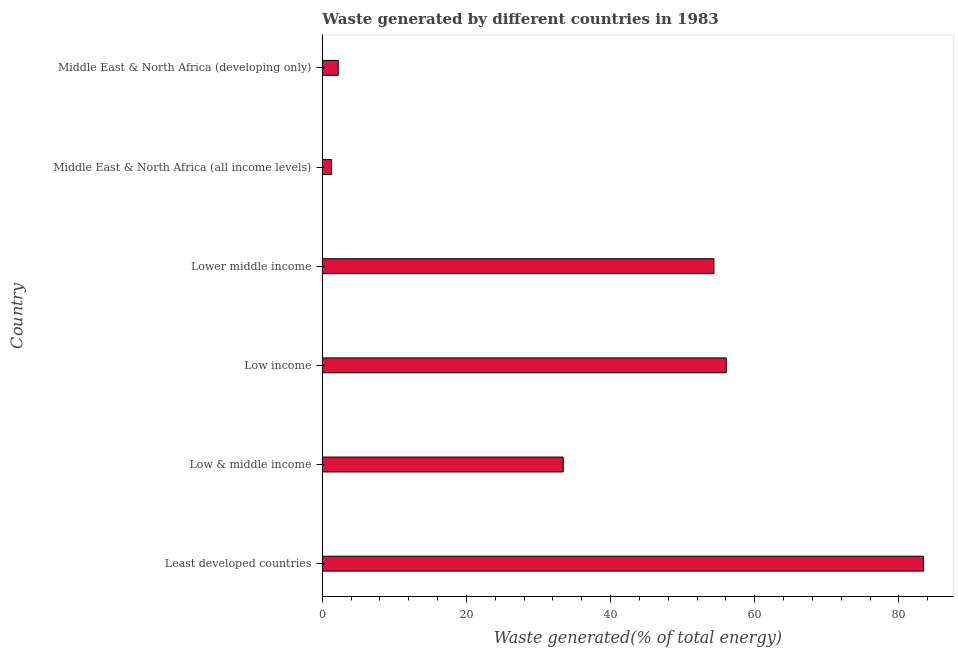What is the title of the graph?
Offer a terse response. Waste generated by different countries in 1983. What is the label or title of the X-axis?
Ensure brevity in your answer.  Waste generated(% of total energy). What is the amount of waste generated in Lower middle income?
Offer a terse response. 54.33. Across all countries, what is the maximum amount of waste generated?
Provide a succinct answer. 83.4. Across all countries, what is the minimum amount of waste generated?
Ensure brevity in your answer.  1.28. In which country was the amount of waste generated maximum?
Provide a succinct answer. Least developed countries. In which country was the amount of waste generated minimum?
Offer a very short reply. Middle East & North Africa (all income levels). What is the sum of the amount of waste generated?
Provide a succinct answer. 230.67. What is the difference between the amount of waste generated in Low & middle income and Lower middle income?
Offer a very short reply. -20.91. What is the average amount of waste generated per country?
Your response must be concise. 38.45. What is the median amount of waste generated?
Keep it short and to the point. 43.88. What is the ratio of the amount of waste generated in Least developed countries to that in Low income?
Offer a terse response. 1.49. Is the amount of waste generated in Low & middle income less than that in Middle East & North Africa (developing only)?
Provide a succinct answer. No. What is the difference between the highest and the second highest amount of waste generated?
Give a very brief answer. 27.36. Is the sum of the amount of waste generated in Low & middle income and Middle East & North Africa (developing only) greater than the maximum amount of waste generated across all countries?
Make the answer very short. No. What is the difference between the highest and the lowest amount of waste generated?
Offer a terse response. 82.12. Are all the bars in the graph horizontal?
Give a very brief answer. Yes. How many countries are there in the graph?
Give a very brief answer. 6. What is the difference between two consecutive major ticks on the X-axis?
Make the answer very short. 20. What is the Waste generated(% of total energy) of Least developed countries?
Make the answer very short. 83.4. What is the Waste generated(% of total energy) of Low & middle income?
Give a very brief answer. 33.42. What is the Waste generated(% of total energy) of Low income?
Give a very brief answer. 56.04. What is the Waste generated(% of total energy) of Lower middle income?
Your response must be concise. 54.33. What is the Waste generated(% of total energy) of Middle East & North Africa (all income levels)?
Provide a short and direct response. 1.28. What is the Waste generated(% of total energy) of Middle East & North Africa (developing only)?
Give a very brief answer. 2.2. What is the difference between the Waste generated(% of total energy) in Least developed countries and Low & middle income?
Make the answer very short. 49.97. What is the difference between the Waste generated(% of total energy) in Least developed countries and Low income?
Provide a succinct answer. 27.36. What is the difference between the Waste generated(% of total energy) in Least developed countries and Lower middle income?
Make the answer very short. 29.07. What is the difference between the Waste generated(% of total energy) in Least developed countries and Middle East & North Africa (all income levels)?
Your answer should be very brief. 82.12. What is the difference between the Waste generated(% of total energy) in Least developed countries and Middle East & North Africa (developing only)?
Ensure brevity in your answer.  81.19. What is the difference between the Waste generated(% of total energy) in Low & middle income and Low income?
Provide a short and direct response. -22.62. What is the difference between the Waste generated(% of total energy) in Low & middle income and Lower middle income?
Provide a succinct answer. -20.91. What is the difference between the Waste generated(% of total energy) in Low & middle income and Middle East & North Africa (all income levels)?
Keep it short and to the point. 32.14. What is the difference between the Waste generated(% of total energy) in Low & middle income and Middle East & North Africa (developing only)?
Your answer should be very brief. 31.22. What is the difference between the Waste generated(% of total energy) in Low income and Lower middle income?
Ensure brevity in your answer.  1.71. What is the difference between the Waste generated(% of total energy) in Low income and Middle East & North Africa (all income levels)?
Offer a very short reply. 54.76. What is the difference between the Waste generated(% of total energy) in Low income and Middle East & North Africa (developing only)?
Offer a terse response. 53.84. What is the difference between the Waste generated(% of total energy) in Lower middle income and Middle East & North Africa (all income levels)?
Your response must be concise. 53.05. What is the difference between the Waste generated(% of total energy) in Lower middle income and Middle East & North Africa (developing only)?
Your answer should be compact. 52.13. What is the difference between the Waste generated(% of total energy) in Middle East & North Africa (all income levels) and Middle East & North Africa (developing only)?
Your response must be concise. -0.92. What is the ratio of the Waste generated(% of total energy) in Least developed countries to that in Low & middle income?
Offer a terse response. 2.5. What is the ratio of the Waste generated(% of total energy) in Least developed countries to that in Low income?
Your answer should be very brief. 1.49. What is the ratio of the Waste generated(% of total energy) in Least developed countries to that in Lower middle income?
Keep it short and to the point. 1.53. What is the ratio of the Waste generated(% of total energy) in Least developed countries to that in Middle East & North Africa (all income levels)?
Give a very brief answer. 65.12. What is the ratio of the Waste generated(% of total energy) in Least developed countries to that in Middle East & North Africa (developing only)?
Offer a terse response. 37.87. What is the ratio of the Waste generated(% of total energy) in Low & middle income to that in Low income?
Ensure brevity in your answer.  0.6. What is the ratio of the Waste generated(% of total energy) in Low & middle income to that in Lower middle income?
Give a very brief answer. 0.61. What is the ratio of the Waste generated(% of total energy) in Low & middle income to that in Middle East & North Africa (all income levels)?
Your answer should be compact. 26.1. What is the ratio of the Waste generated(% of total energy) in Low & middle income to that in Middle East & North Africa (developing only)?
Keep it short and to the point. 15.18. What is the ratio of the Waste generated(% of total energy) in Low income to that in Lower middle income?
Give a very brief answer. 1.03. What is the ratio of the Waste generated(% of total energy) in Low income to that in Middle East & North Africa (all income levels)?
Your response must be concise. 43.76. What is the ratio of the Waste generated(% of total energy) in Low income to that in Middle East & North Africa (developing only)?
Offer a terse response. 25.44. What is the ratio of the Waste generated(% of total energy) in Lower middle income to that in Middle East & North Africa (all income levels)?
Ensure brevity in your answer.  42.42. What is the ratio of the Waste generated(% of total energy) in Lower middle income to that in Middle East & North Africa (developing only)?
Give a very brief answer. 24.67. What is the ratio of the Waste generated(% of total energy) in Middle East & North Africa (all income levels) to that in Middle East & North Africa (developing only)?
Offer a terse response. 0.58. 